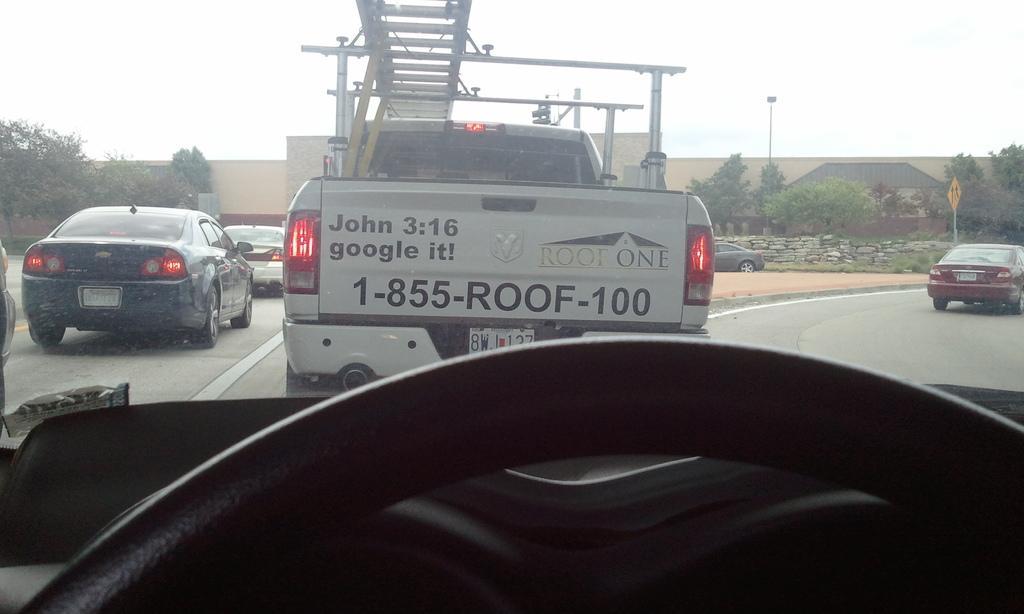Describe this image in one or two sentences. We can see vehicles on the road. On the background we can see wall, board and light on poles,trees and sky. 